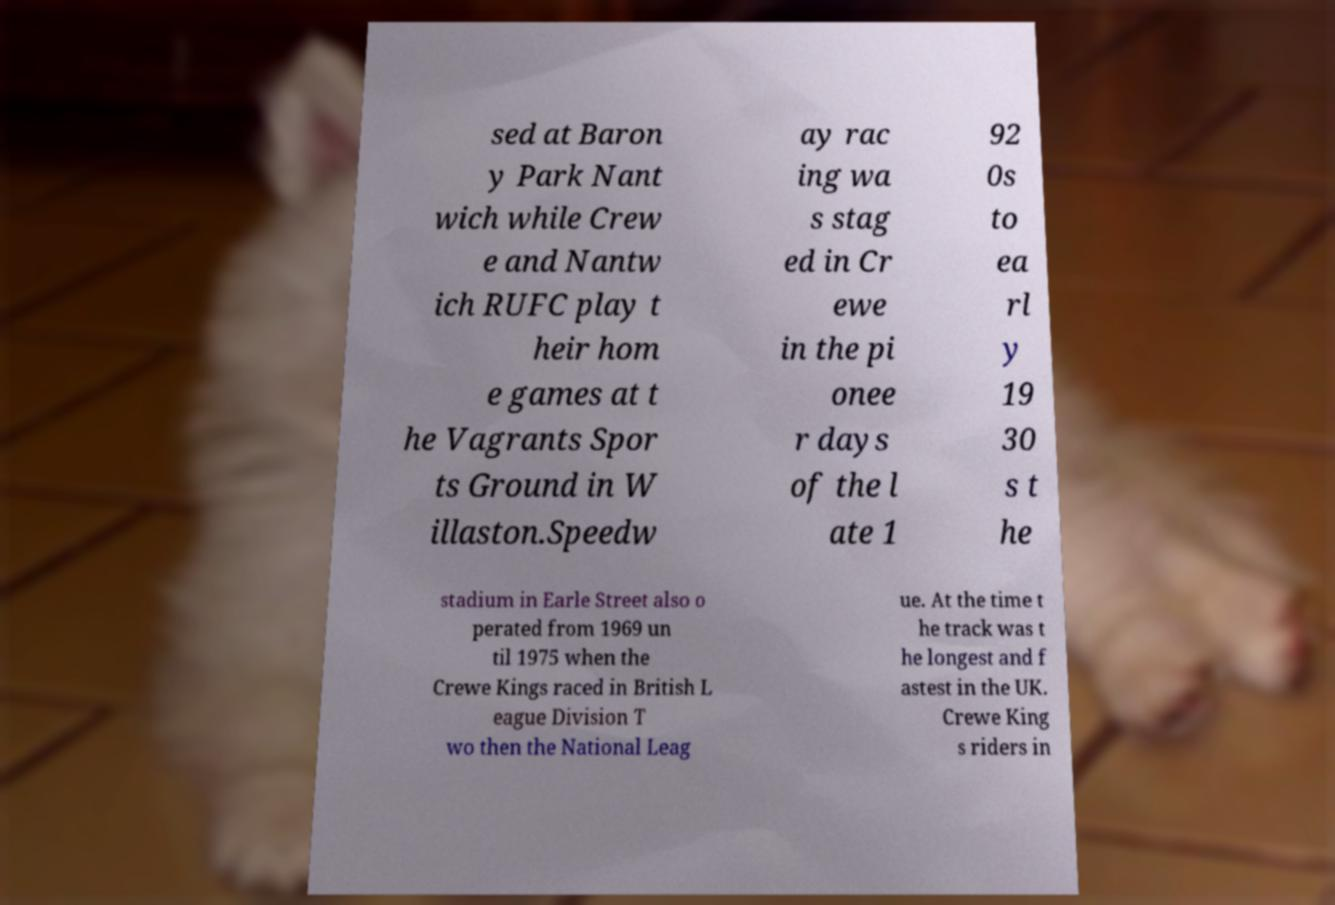Can you accurately transcribe the text from the provided image for me? sed at Baron y Park Nant wich while Crew e and Nantw ich RUFC play t heir hom e games at t he Vagrants Spor ts Ground in W illaston.Speedw ay rac ing wa s stag ed in Cr ewe in the pi onee r days of the l ate 1 92 0s to ea rl y 19 30 s t he stadium in Earle Street also o perated from 1969 un til 1975 when the Crewe Kings raced in British L eague Division T wo then the National Leag ue. At the time t he track was t he longest and f astest in the UK. Crewe King s riders in 